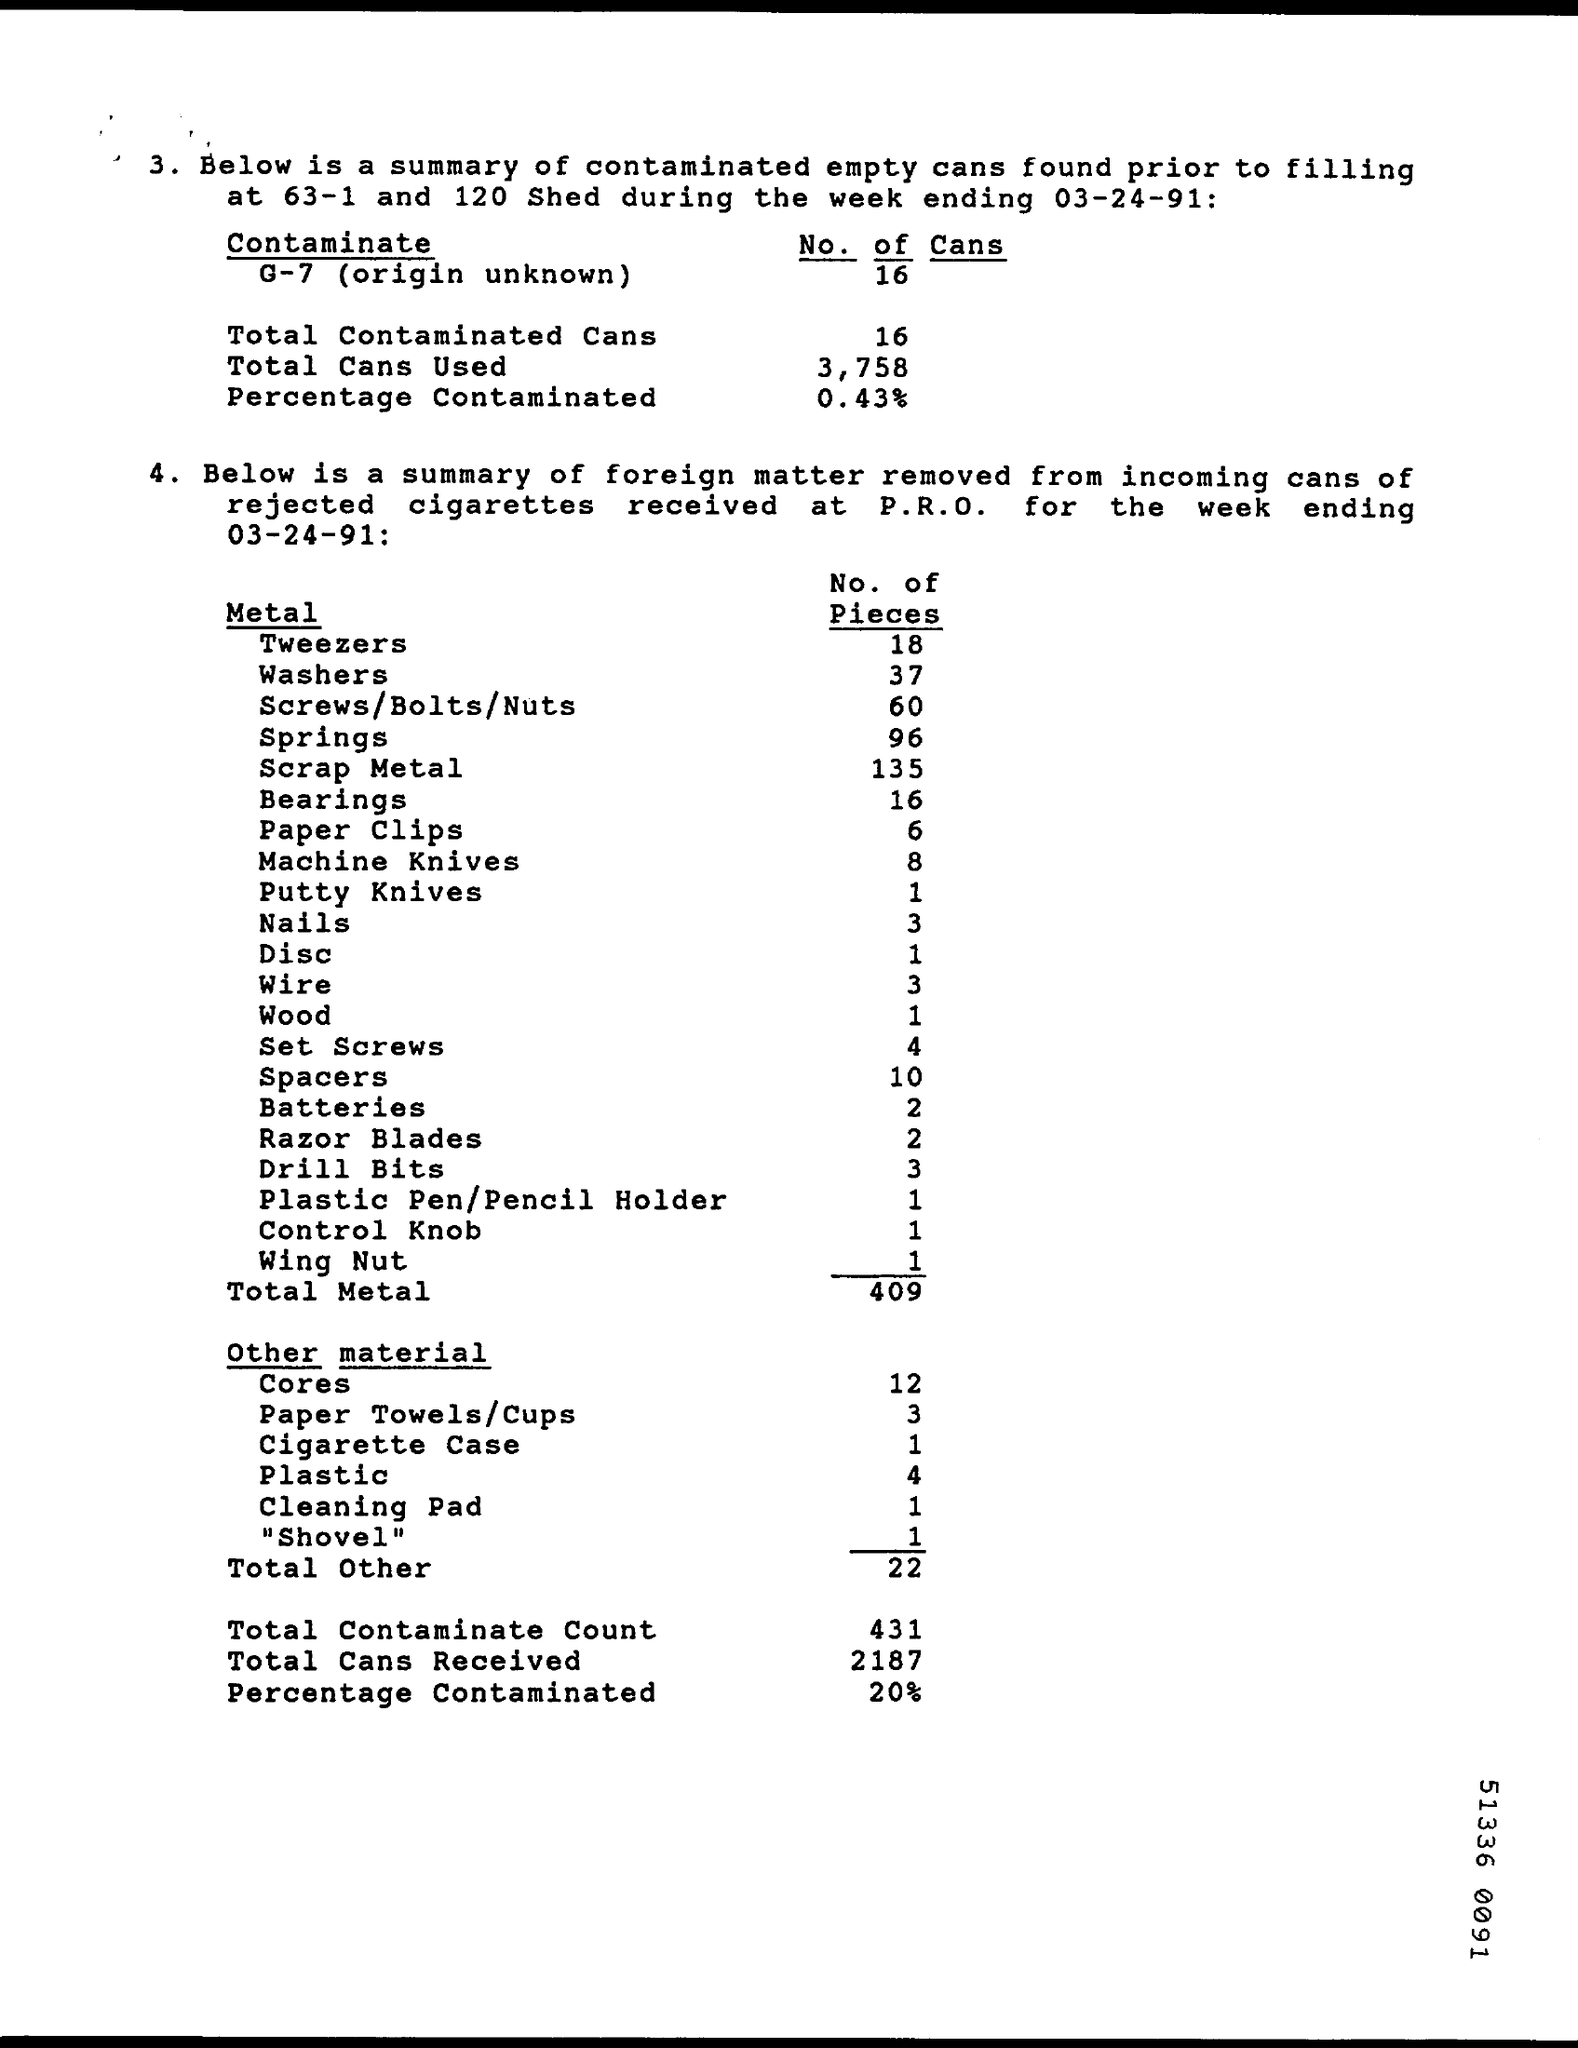How many pieces of batteries were found?
Provide a short and direct response. 2. What is the Total Contaminate Count?
Provide a short and direct response. 431. 